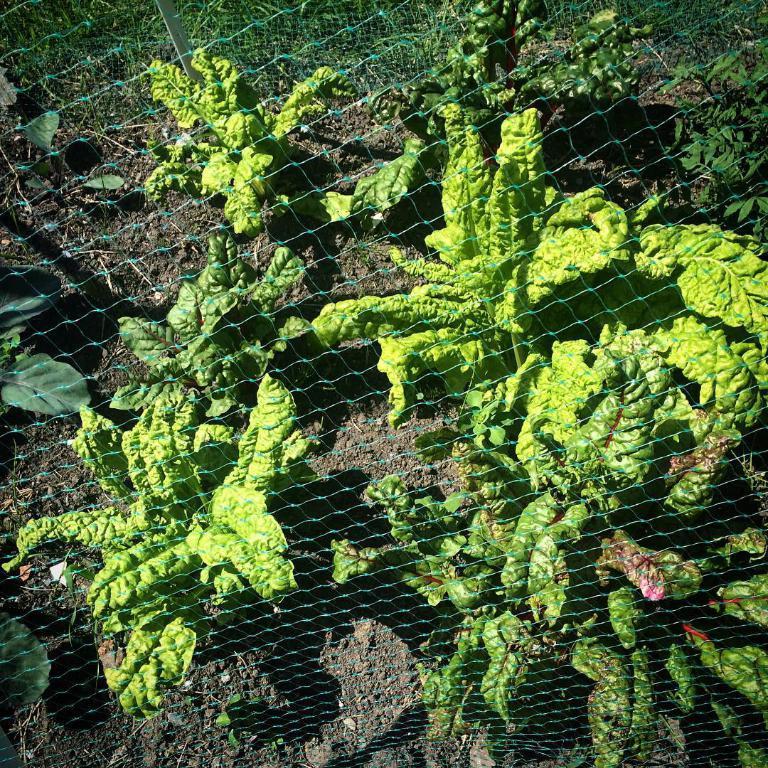How would you summarize this image in a sentence or two? In this picture I can see few plants and I can see net. 